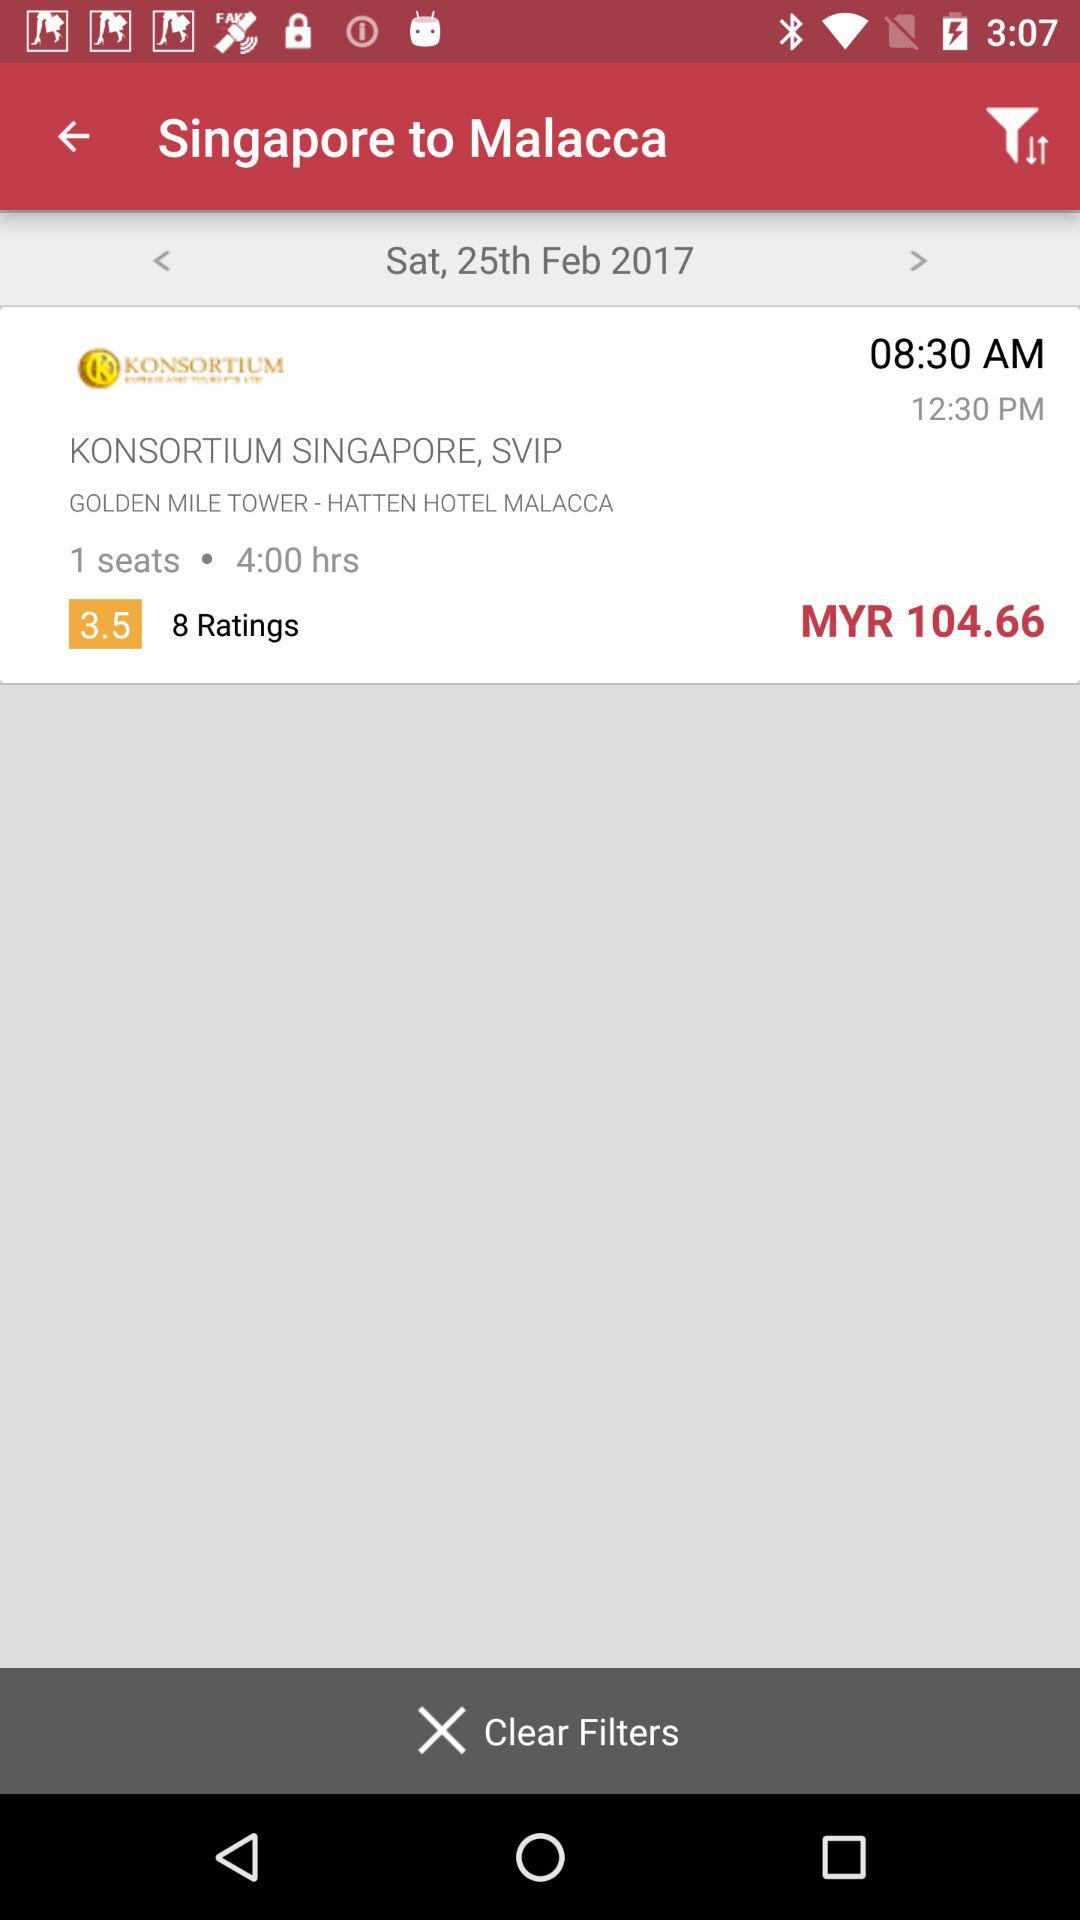What is the rating? The rating is 3.5. 